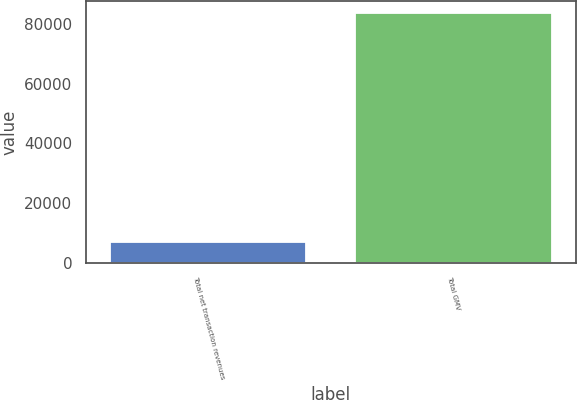Convert chart. <chart><loc_0><loc_0><loc_500><loc_500><bar_chart><fcel>Total net transaction revenues<fcel>Total GMV<nl><fcel>7044<fcel>83488<nl></chart> 